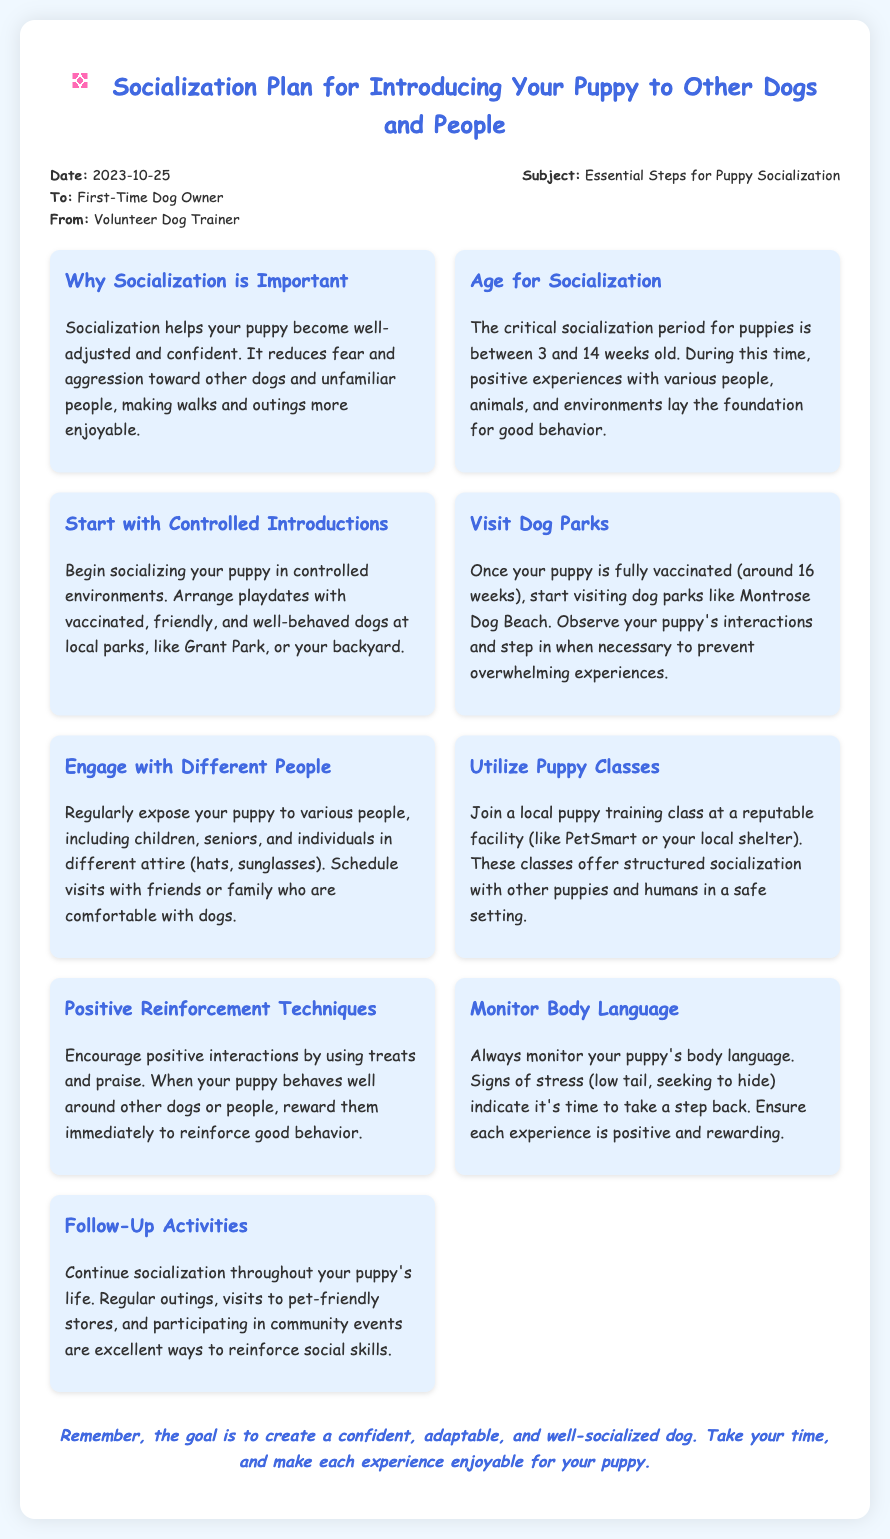What is the date of the memo? The date is specified at the top of the memo.
Answer: 2023-10-25 Who is the memo addressed to? The recipient of the memo is mentioned in the header.
Answer: First-Time Dog Owner What is the subject of the memo? The subject is provided in the header section.
Answer: Essential Steps for Puppy Socialization What is the critical socialization period for puppies? The memo states the age range considered critical for socialization.
Answer: 3 and 14 weeks old What should you do after your puppy is fully vaccinated? The document recommends an activity to start once the puppy is vaccinated.
Answer: Start visiting dog parks What technique is suggested for encouraging positive interactions? The memo offers a method to reinforce good behavior during socialization.
Answer: Positive Reinforcement Techniques What can indicate that a puppy is stressed? The memo lists specific signs to look for regarding stress in puppies.
Answer: Low tail, seeking to hide What is a follow-up activity for continued socialization? The document suggests ongoing activities to maintain social skills.
Answer: Regular outings Why is socialization important? The memo explains the benefits of socialization for puppies.
Answer: Reduces fear and aggression 